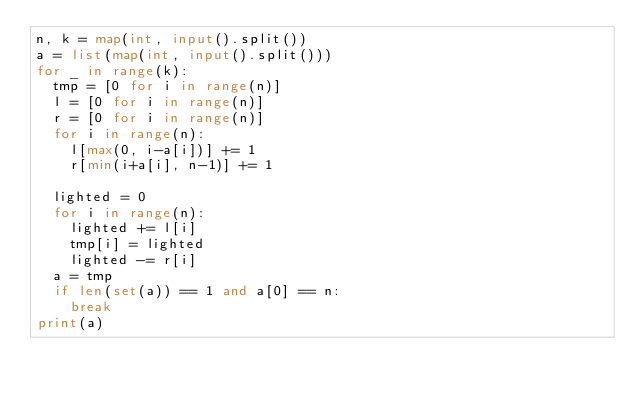<code> <loc_0><loc_0><loc_500><loc_500><_Python_>n, k = map(int, input().split())
a = list(map(int, input().split()))
for _ in range(k):
  tmp = [0 for i in range(n)]
  l = [0 for i in range(n)]
  r = [0 for i in range(n)]
  for i in range(n):
    l[max(0, i-a[i])] += 1
    r[min(i+a[i], n-1)] += 1
    
  lighted = 0
  for i in range(n):
    lighted += l[i]
    tmp[i] = lighted
    lighted -= r[i]
  a = tmp
  if len(set(a)) == 1 and a[0] == n:
    break
print(a)
</code> 